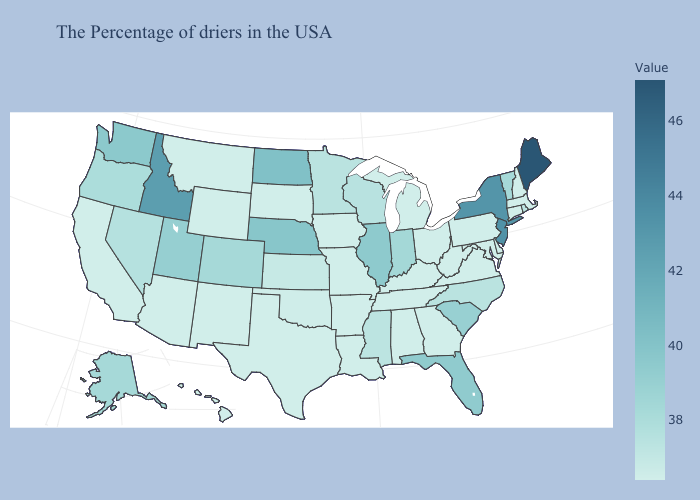Among the states that border New York , does New Jersey have the highest value?
Write a very short answer. Yes. Does Maine have the highest value in the USA?
Give a very brief answer. Yes. Does New Jersey have a lower value than Maine?
Give a very brief answer. Yes. 